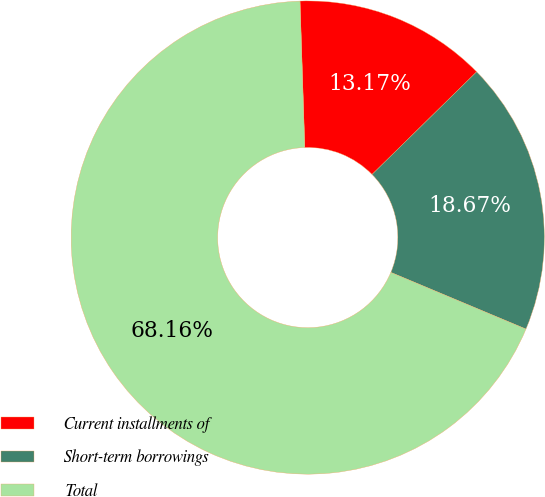<chart> <loc_0><loc_0><loc_500><loc_500><pie_chart><fcel>Current installments of<fcel>Short-term borrowings<fcel>Total<nl><fcel>13.17%<fcel>18.67%<fcel>68.16%<nl></chart> 